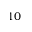Convert formula to latex. <formula><loc_0><loc_0><loc_500><loc_500>1 0</formula> 